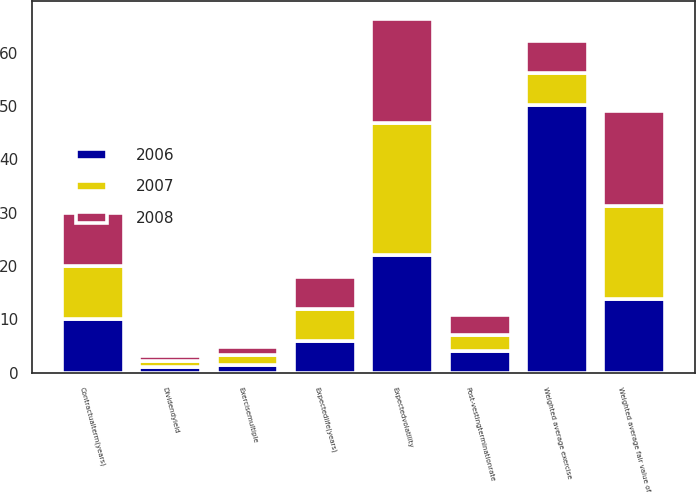Convert chart. <chart><loc_0><loc_0><loc_500><loc_500><stacked_bar_chart><ecel><fcel>Dividendyield<fcel>Expectedvolatility<fcel>Exercisemultiple<fcel>Post-vestingterminationrate<fcel>Contractualterm(years)<fcel>Expectedlife(years)<fcel>Weighted average exercise<fcel>Weighted average fair value of<nl><fcel>2007<fcel>1.21<fcel>24.85<fcel>1.73<fcel>3.05<fcel>10<fcel>6<fcel>6<fcel>17.51<nl><fcel>2008<fcel>0.94<fcel>19.54<fcel>1.66<fcel>3.66<fcel>10<fcel>6<fcel>6<fcel>17.76<nl><fcel>2006<fcel>1.04<fcel>22<fcel>1.52<fcel>4.09<fcel>10<fcel>6<fcel>50.21<fcel>13.84<nl></chart> 